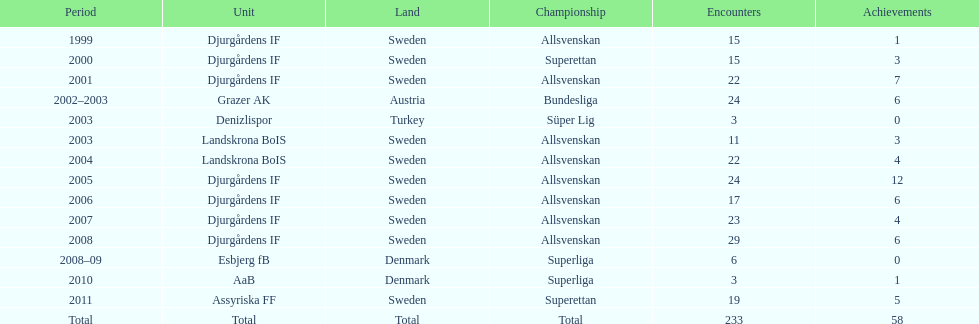How many matches overall were there? 233. 